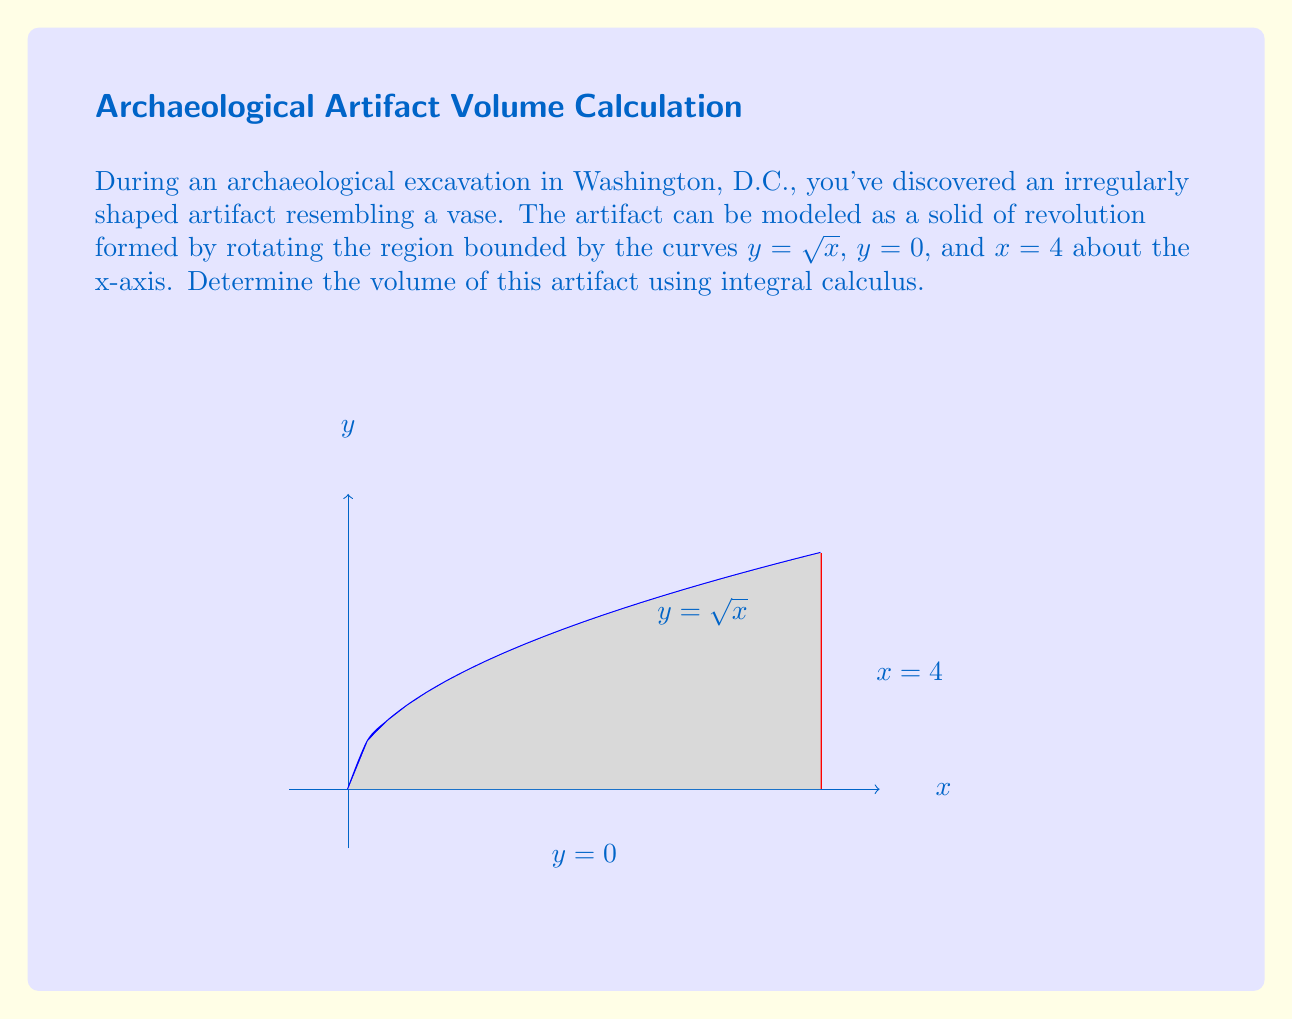Solve this math problem. To solve this problem, we'll use the washer method for calculating the volume of a solid of revolution:

1) The volume is given by the formula:
   $$V = \pi \int_a^b [R(x)^2 - r(x)^2] dx$$
   where $R(x)$ is the outer radius and $r(x)$ is the inner radius.

2) In this case, $R(x) = \sqrt{x}$ and $r(x) = 0$. The limits of integration are from $a = 0$ to $b = 4$.

3) Substituting these into our formula:
   $$V = \pi \int_0^4 [(\sqrt{x})^2 - 0^2] dx = \pi \int_0^4 x dx$$

4) Evaluate the integral:
   $$V = \pi [\frac{1}{2}x^2]_0^4 = \pi (\frac{1}{2} \cdot 4^2 - 0) = 8\pi$$

5) Therefore, the volume of the artifact is $8\pi$ cubic units.
Answer: $8\pi$ cubic units 